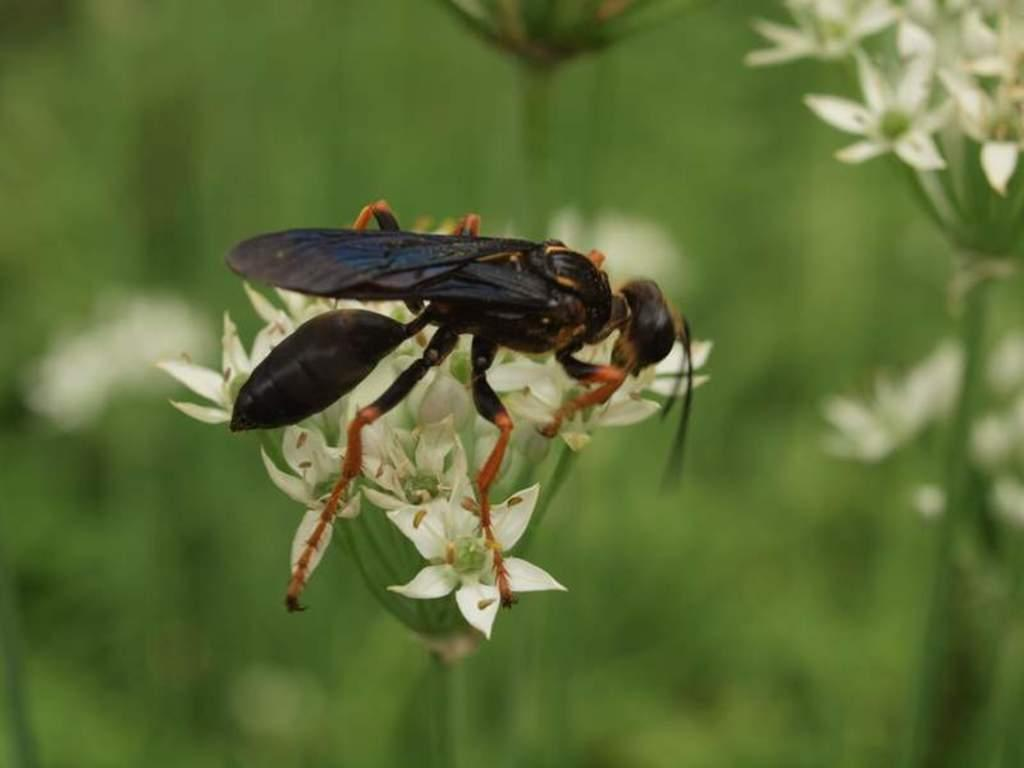What is the main subject of the image? The main subject of the image is an inset on a flower. Where are the flowers located in the image? There are flowers in the right side top corner of the image. What colors can be seen in the background of the image? The background of the image is blue and green in color. Can you tell me how many mines are present in the image? There are no mines present in the image; it features an inset on a flower and other flowers in the background. What type of grass is growing in the image? There is no grass visible in the image; it features a flower with an inset and a blue and green background. 